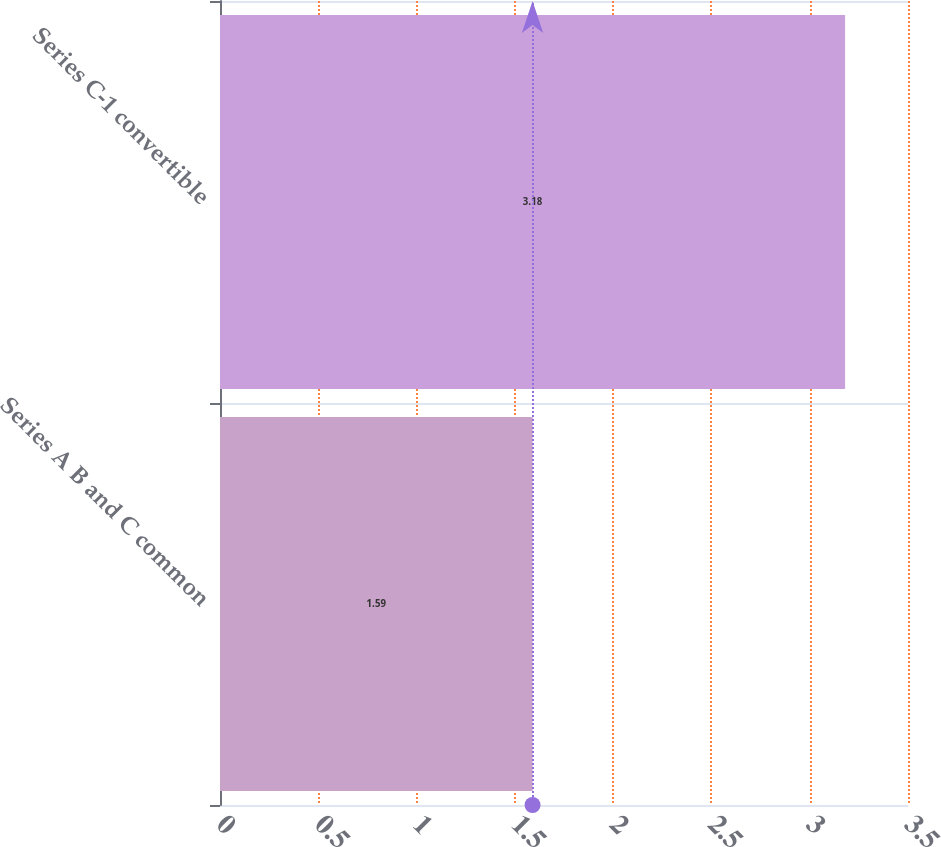Convert chart to OTSL. <chart><loc_0><loc_0><loc_500><loc_500><bar_chart><fcel>Series A B and C common<fcel>Series C-1 convertible<nl><fcel>1.59<fcel>3.18<nl></chart> 